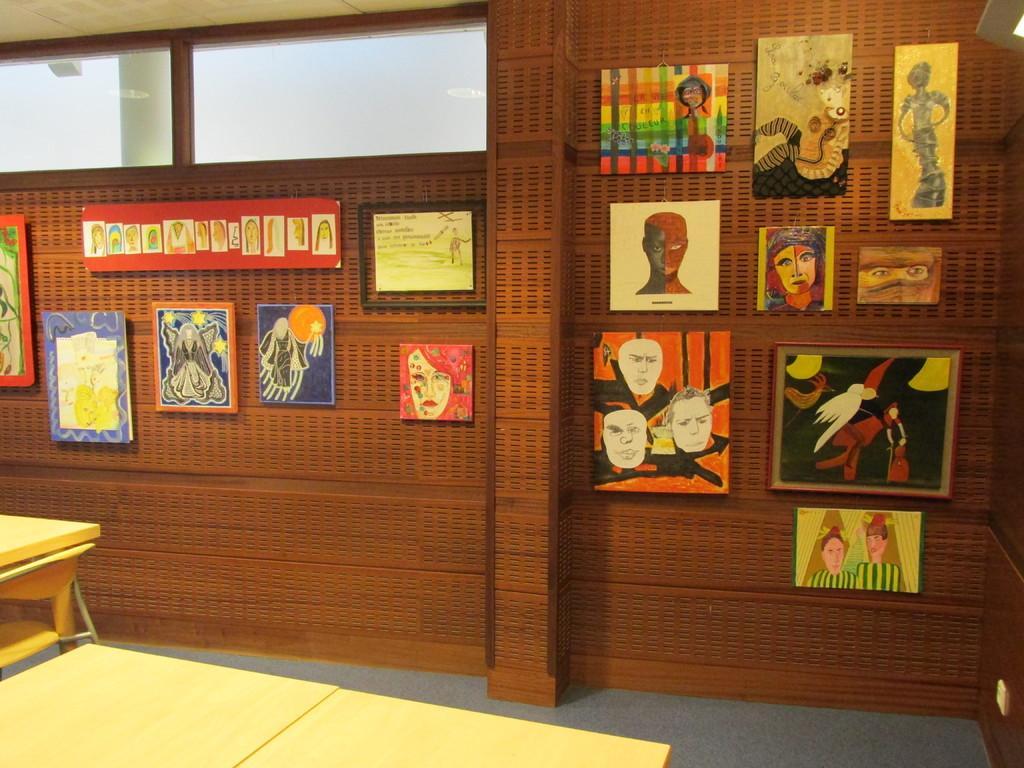In one or two sentences, can you explain what this image depicts? In this image we can see tables, glass, floor, and frames on the wall. 